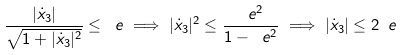<formula> <loc_0><loc_0><loc_500><loc_500>\frac { | \dot { x } _ { 3 } | } { \sqrt { 1 + | \dot { x } _ { 3 } | ^ { 2 } } } \leq \ e \implies | \dot { x } _ { 3 } | ^ { 2 } \leq \frac { \ e ^ { 2 } } { 1 - \ e ^ { 2 } } \implies | \dot { x } _ { 3 } | \leq 2 \ e</formula> 